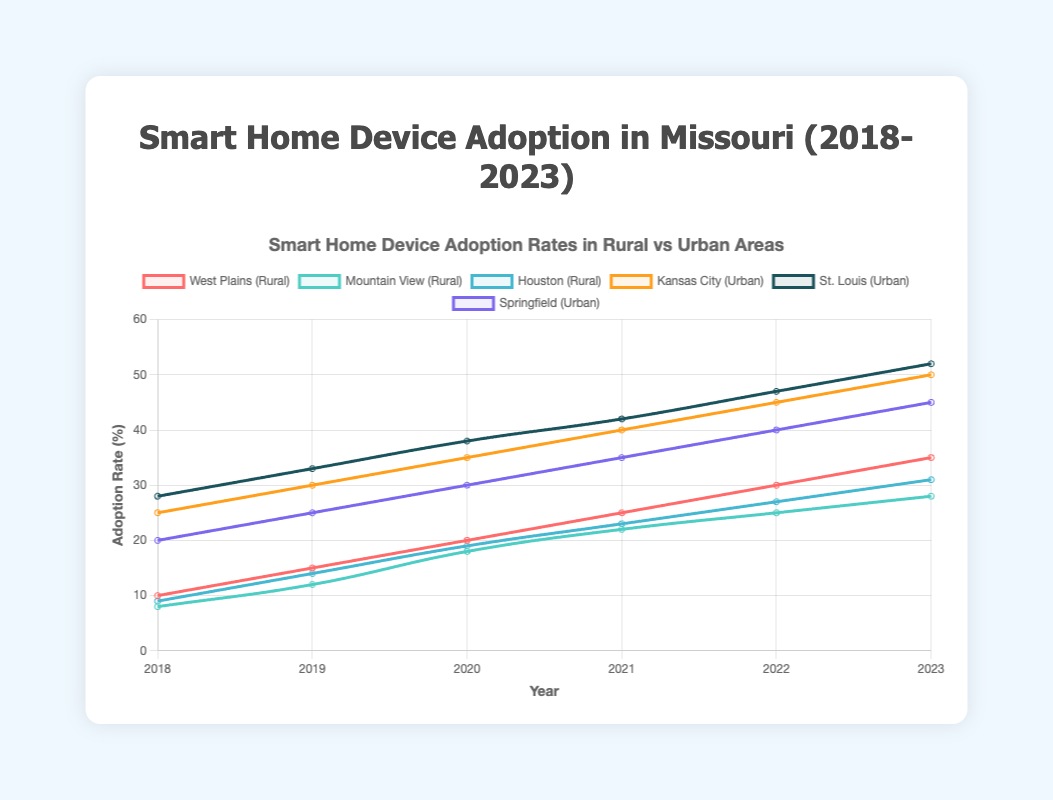Which area saw the highest adoption rate in 2023? In 2023, the highest adoption rate is the data point with the tallest line on the plot. St. Louis shows 52%, Kansas City 50%, Springfield 45%, West Plains 35%, Houston 31%, and Mountain View 28%. Hence, St. Louis had the highest adoption rate among all areas.
Answer: St. Louis What is the adoption rate difference between West Plains and Mountain View in 2019? Look at the plot for the year 2019, locate the adoption rates for West Plains (15%) and Mountain View (12%). Subtract the adoption rate of Mountain View from West Plains: 15% - 12% = 3%.
Answer: 3% What is the average adoption rate in St. Louis from 2020 to 2023? Identify adoption rates for St. Louis from 2020 to 2023 on the plot (38%, 42%, 47%, 52%). Calculate the average: (38 + 42 + 47 + 52) / 4 = 44.75%.
Answer: 44.75% Which rural area had the slowest rate of adoption from 2018 to 2023? Compare the slopes of the lines representing rural areas (West Plains, Mountain View, and Houston). Mountain View's line is not as steep as others, indicating the slowest increase in adoption rate over the years.
Answer: Mountain View In 2020, which urban area had the highest adoption rate and by how much more than the lowest adoption rate in rural areas? In 2020 among urban areas, St. Louis had the highest adoption rate (38%), and Mountain View had the lowest adoption rate among rural areas (18%). Calculate the difference: 38% - 18% = 20%.
Answer: St. Louis, 20% How much did the adoption rate of Smart Home Devices in Kansas City increase from 2018 to 2021? In 2018, Kansas City's adoption rate was 25%, and in 2021, it was 40%. Subtract the 2018 rate from the 2021 rate: 40% - 25% = 15%.
Answer: 15% Between Houston and West Plains, which had a higher adoption rate in 2023, and what was the percentage difference? For 2023, West Plains had an adoption rate of 35%, while Houston had 31%. Find the difference: 35% - 31% = 4%. So, West Plains had a higher adoption rate by 4%.
Answer: West Plains, 4% Which year saw the sharpest increase in adoption rate for Springfield? Examine the plot for Springfield's line and compare yearly increments. The sharpest increase is between 2018 (20%) to 2019 (25%), showing a 5% increase, which is the most significant one.
Answer: 2019 Compare the adoption rates of St. Louis and Kansas City in 2022 and state the higher one. In 2022, St. Louis had an adoption rate of 47%, and Kansas City had 45%. St. Louis had a higher adoption rate than Kansas City by 2%.
Answer: St. Louis 